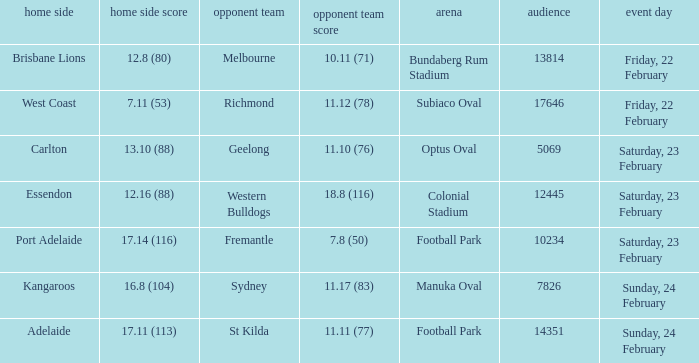What score did the away team receive against home team Port Adelaide? 7.8 (50). 